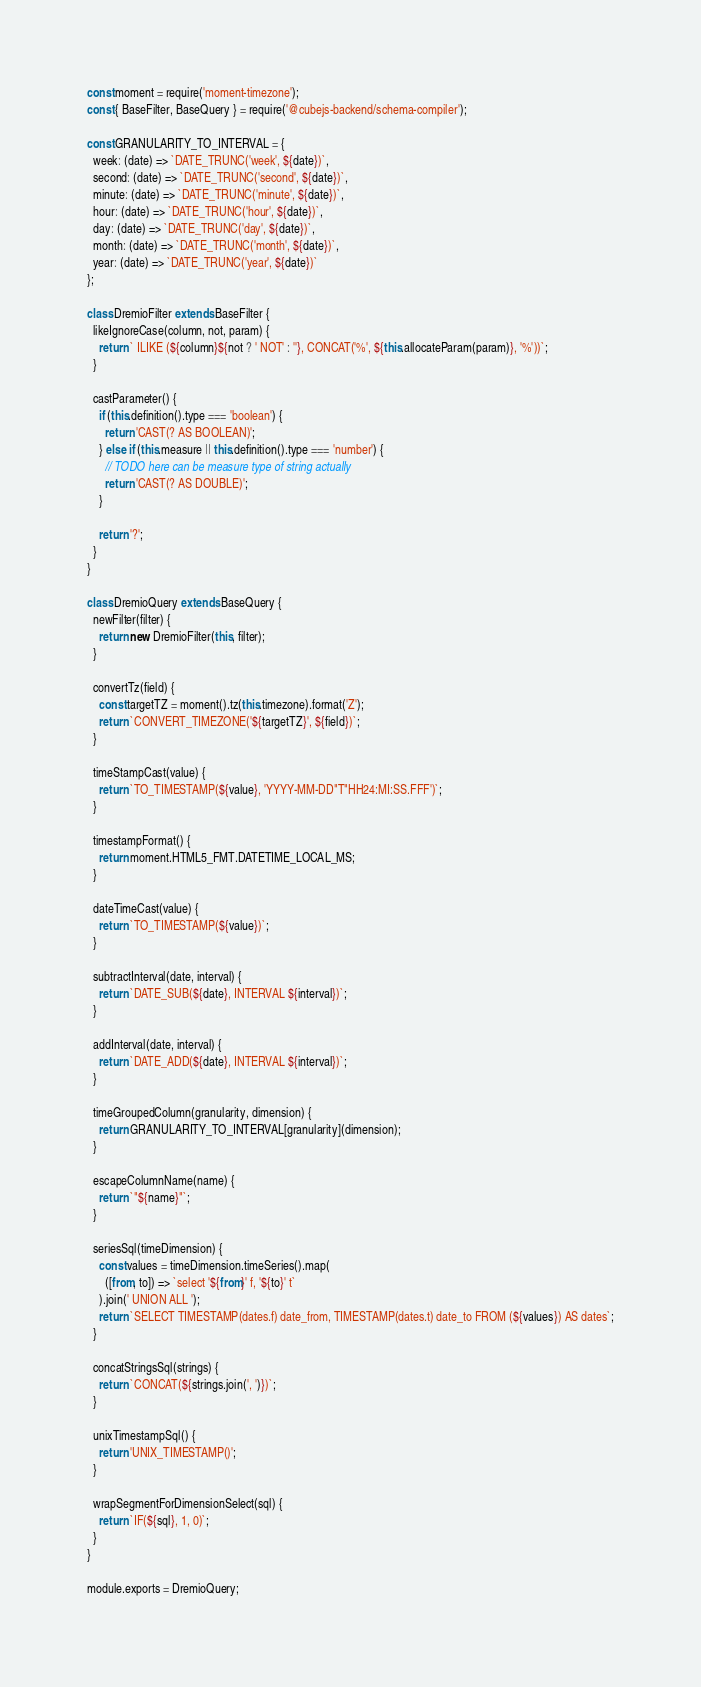<code> <loc_0><loc_0><loc_500><loc_500><_JavaScript_>const moment = require('moment-timezone');
const { BaseFilter, BaseQuery } = require('@cubejs-backend/schema-compiler');

const GRANULARITY_TO_INTERVAL = {
  week: (date) => `DATE_TRUNC('week', ${date})`,
  second: (date) => `DATE_TRUNC('second', ${date})`,
  minute: (date) => `DATE_TRUNC('minute', ${date})`,
  hour: (date) => `DATE_TRUNC('hour', ${date})`,
  day: (date) => `DATE_TRUNC('day', ${date})`,
  month: (date) => `DATE_TRUNC('month', ${date})`,
  year: (date) => `DATE_TRUNC('year', ${date})`
};

class DremioFilter extends BaseFilter {
  likeIgnoreCase(column, not, param) {
    return ` ILIKE (${column}${not ? ' NOT' : ''}, CONCAT('%', ${this.allocateParam(param)}, '%'))`;
  }

  castParameter() {
    if (this.definition().type === 'boolean') {
      return 'CAST(? AS BOOLEAN)';
    } else if (this.measure || this.definition().type === 'number') {
      // TODO here can be measure type of string actually
      return 'CAST(? AS DOUBLE)';
    }

    return '?';
  }
}

class DremioQuery extends BaseQuery {
  newFilter(filter) {
    return new DremioFilter(this, filter);
  }

  convertTz(field) {
    const targetTZ = moment().tz(this.timezone).format('Z');
    return `CONVERT_TIMEZONE('${targetTZ}', ${field})`;
  }

  timeStampCast(value) {
    return `TO_TIMESTAMP(${value}, 'YYYY-MM-DD"T"HH24:MI:SS.FFF')`;
  }

  timestampFormat() {
    return moment.HTML5_FMT.DATETIME_LOCAL_MS;
  }

  dateTimeCast(value) {
    return `TO_TIMESTAMP(${value})`;
  }

  subtractInterval(date, interval) {
    return `DATE_SUB(${date}, INTERVAL ${interval})`;
  }

  addInterval(date, interval) {
    return `DATE_ADD(${date}, INTERVAL ${interval})`;
  }

  timeGroupedColumn(granularity, dimension) {
    return GRANULARITY_TO_INTERVAL[granularity](dimension);
  }

  escapeColumnName(name) {
    return `"${name}"`;
  }

  seriesSql(timeDimension) {
    const values = timeDimension.timeSeries().map(
      ([from, to]) => `select '${from}' f, '${to}' t`
    ).join(' UNION ALL ');
    return `SELECT TIMESTAMP(dates.f) date_from, TIMESTAMP(dates.t) date_to FROM (${values}) AS dates`;
  }

  concatStringsSql(strings) {
    return `CONCAT(${strings.join(', ')})`;
  }

  unixTimestampSql() {
    return 'UNIX_TIMESTAMP()';
  }

  wrapSegmentForDimensionSelect(sql) {
    return `IF(${sql}, 1, 0)`;
  }
}

module.exports = DremioQuery;
</code> 